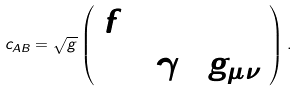<formula> <loc_0><loc_0><loc_500><loc_500>c _ { A B } = \sqrt { g } \left ( \begin{array} { l l } { f } & { 0 } \\ { 0 } & { { 2 \gamma \Phi g _ { \mu \nu } } } \end{array} \right ) .</formula> 